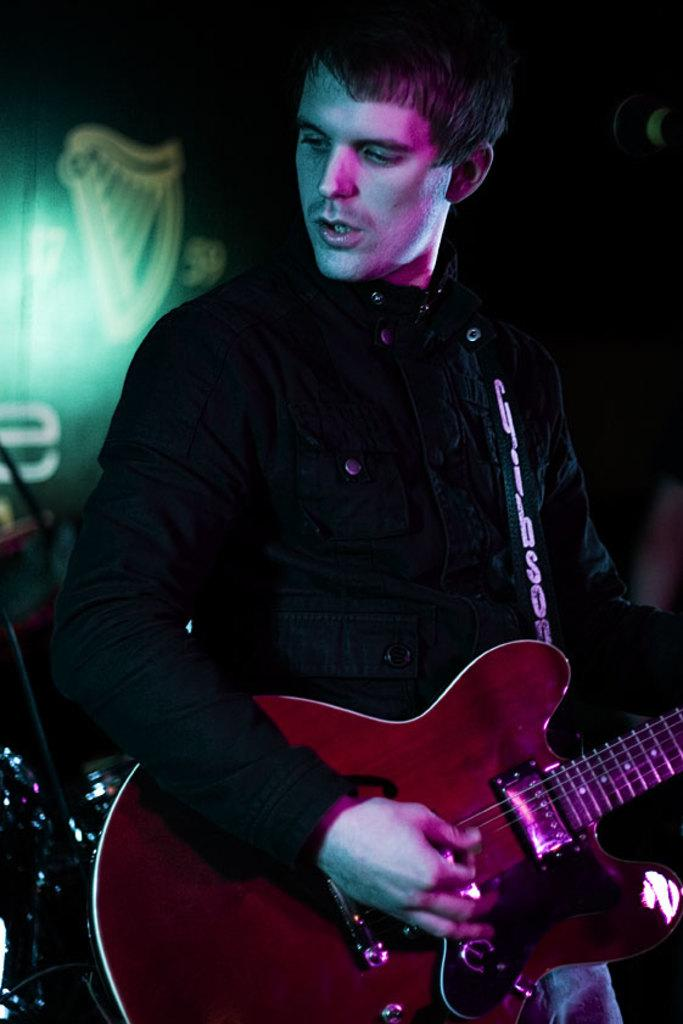What is the main subject of the image? The main subject of the image is a man. What is the man wearing in the image? The man is wearing a black jacket. What activity is the man engaged in? The man is playing a guitar. What can be seen in the background of the image? There is a light visible in the background of the image. What type of land can be seen in the image? There is no land visible in the image; it features a man playing a guitar. What is the man using to control the poison in the image? There is no mention of poison or any related objects in the image. 